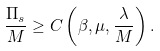Convert formula to latex. <formula><loc_0><loc_0><loc_500><loc_500>\frac { \Pi _ { s } } { M } \geq C \left ( \beta , \mu , \frac { \lambda } { M } \right ) .</formula> 